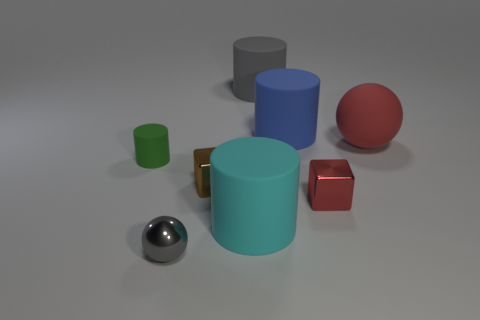There is a tiny thing in front of the red shiny thing; is it the same color as the matte object behind the blue cylinder?
Your response must be concise. Yes. Does the tiny metal block that is right of the gray rubber cylinder have the same color as the matte sphere?
Your answer should be compact. Yes. Are there any gray matte objects of the same size as the blue cylinder?
Ensure brevity in your answer.  Yes. How many large purple metal things are there?
Provide a short and direct response. 0. There is a blue cylinder; how many tiny metal blocks are to the right of it?
Your answer should be very brief. 1. Do the blue cylinder and the gray sphere have the same material?
Your response must be concise. No. How many objects are in front of the tiny green matte cylinder and right of the brown metallic thing?
Offer a very short reply. 2. How many other things are the same color as the tiny sphere?
Keep it short and to the point. 1. How many brown objects are either large objects or tiny balls?
Offer a terse response. 0. How big is the cyan matte cylinder?
Your answer should be compact. Large. 